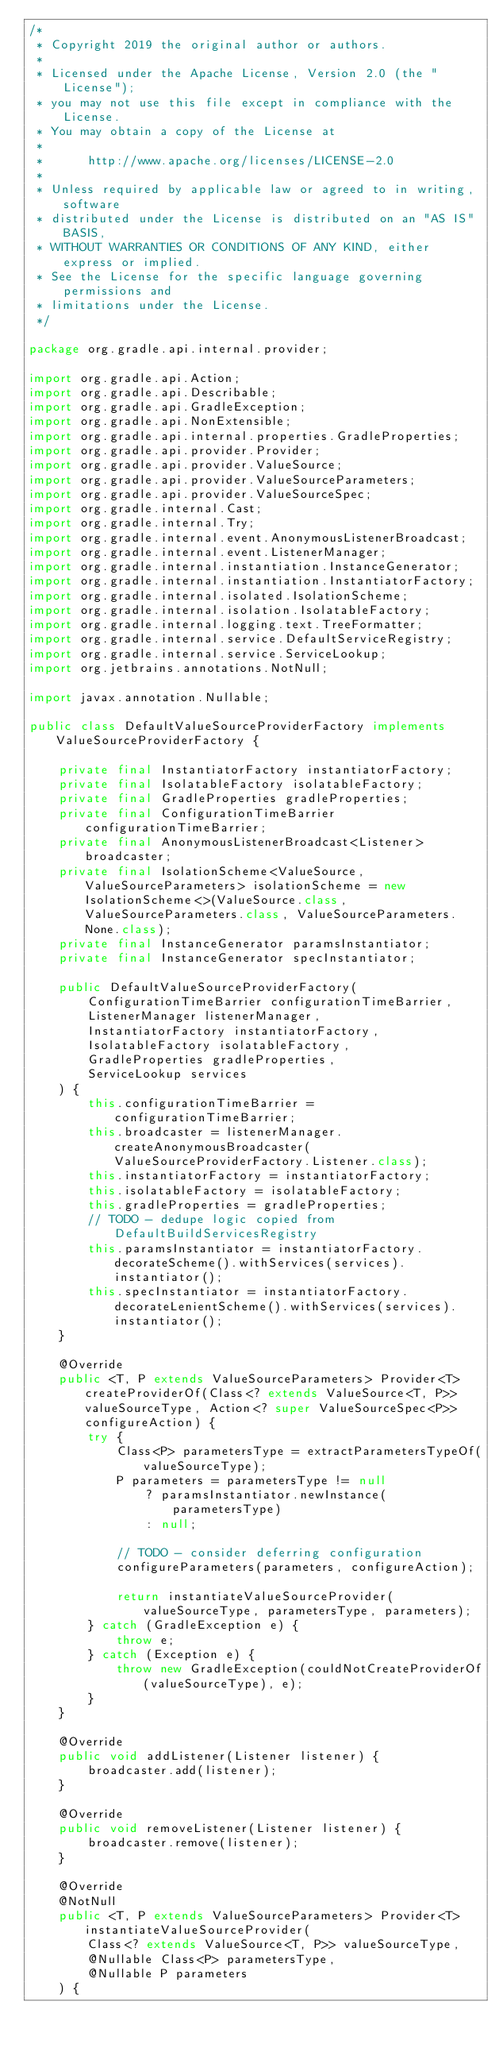<code> <loc_0><loc_0><loc_500><loc_500><_Java_>/*
 * Copyright 2019 the original author or authors.
 *
 * Licensed under the Apache License, Version 2.0 (the "License");
 * you may not use this file except in compliance with the License.
 * You may obtain a copy of the License at
 *
 *      http://www.apache.org/licenses/LICENSE-2.0
 *
 * Unless required by applicable law or agreed to in writing, software
 * distributed under the License is distributed on an "AS IS" BASIS,
 * WITHOUT WARRANTIES OR CONDITIONS OF ANY KIND, either express or implied.
 * See the License for the specific language governing permissions and
 * limitations under the License.
 */

package org.gradle.api.internal.provider;

import org.gradle.api.Action;
import org.gradle.api.Describable;
import org.gradle.api.GradleException;
import org.gradle.api.NonExtensible;
import org.gradle.api.internal.properties.GradleProperties;
import org.gradle.api.provider.Provider;
import org.gradle.api.provider.ValueSource;
import org.gradle.api.provider.ValueSourceParameters;
import org.gradle.api.provider.ValueSourceSpec;
import org.gradle.internal.Cast;
import org.gradle.internal.Try;
import org.gradle.internal.event.AnonymousListenerBroadcast;
import org.gradle.internal.event.ListenerManager;
import org.gradle.internal.instantiation.InstanceGenerator;
import org.gradle.internal.instantiation.InstantiatorFactory;
import org.gradle.internal.isolated.IsolationScheme;
import org.gradle.internal.isolation.IsolatableFactory;
import org.gradle.internal.logging.text.TreeFormatter;
import org.gradle.internal.service.DefaultServiceRegistry;
import org.gradle.internal.service.ServiceLookup;
import org.jetbrains.annotations.NotNull;

import javax.annotation.Nullable;

public class DefaultValueSourceProviderFactory implements ValueSourceProviderFactory {

    private final InstantiatorFactory instantiatorFactory;
    private final IsolatableFactory isolatableFactory;
    private final GradleProperties gradleProperties;
    private final ConfigurationTimeBarrier configurationTimeBarrier;
    private final AnonymousListenerBroadcast<Listener> broadcaster;
    private final IsolationScheme<ValueSource, ValueSourceParameters> isolationScheme = new IsolationScheme<>(ValueSource.class, ValueSourceParameters.class, ValueSourceParameters.None.class);
    private final InstanceGenerator paramsInstantiator;
    private final InstanceGenerator specInstantiator;

    public DefaultValueSourceProviderFactory(
        ConfigurationTimeBarrier configurationTimeBarrier,
        ListenerManager listenerManager,
        InstantiatorFactory instantiatorFactory,
        IsolatableFactory isolatableFactory,
        GradleProperties gradleProperties,
        ServiceLookup services
    ) {
        this.configurationTimeBarrier = configurationTimeBarrier;
        this.broadcaster = listenerManager.createAnonymousBroadcaster(ValueSourceProviderFactory.Listener.class);
        this.instantiatorFactory = instantiatorFactory;
        this.isolatableFactory = isolatableFactory;
        this.gradleProperties = gradleProperties;
        // TODO - dedupe logic copied from DefaultBuildServicesRegistry
        this.paramsInstantiator = instantiatorFactory.decorateScheme().withServices(services).instantiator();
        this.specInstantiator = instantiatorFactory.decorateLenientScheme().withServices(services).instantiator();
    }

    @Override
    public <T, P extends ValueSourceParameters> Provider<T> createProviderOf(Class<? extends ValueSource<T, P>> valueSourceType, Action<? super ValueSourceSpec<P>> configureAction) {
        try {
            Class<P> parametersType = extractParametersTypeOf(valueSourceType);
            P parameters = parametersType != null
                ? paramsInstantiator.newInstance(parametersType)
                : null;

            // TODO - consider deferring configuration
            configureParameters(parameters, configureAction);

            return instantiateValueSourceProvider(valueSourceType, parametersType, parameters);
        } catch (GradleException e) {
            throw e;
        } catch (Exception e) {
            throw new GradleException(couldNotCreateProviderOf(valueSourceType), e);
        }
    }

    @Override
    public void addListener(Listener listener) {
        broadcaster.add(listener);
    }

    @Override
    public void removeListener(Listener listener) {
        broadcaster.remove(listener);
    }

    @Override
    @NotNull
    public <T, P extends ValueSourceParameters> Provider<T> instantiateValueSourceProvider(
        Class<? extends ValueSource<T, P>> valueSourceType,
        @Nullable Class<P> parametersType,
        @Nullable P parameters
    ) {</code> 